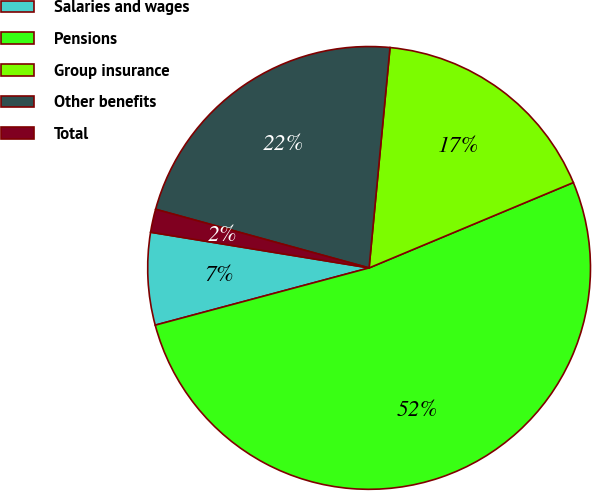Convert chart. <chart><loc_0><loc_0><loc_500><loc_500><pie_chart><fcel>Salaries and wages<fcel>Pensions<fcel>Group insurance<fcel>Other benefits<fcel>Total<nl><fcel>6.74%<fcel>52.14%<fcel>17.19%<fcel>22.24%<fcel>1.69%<nl></chart> 